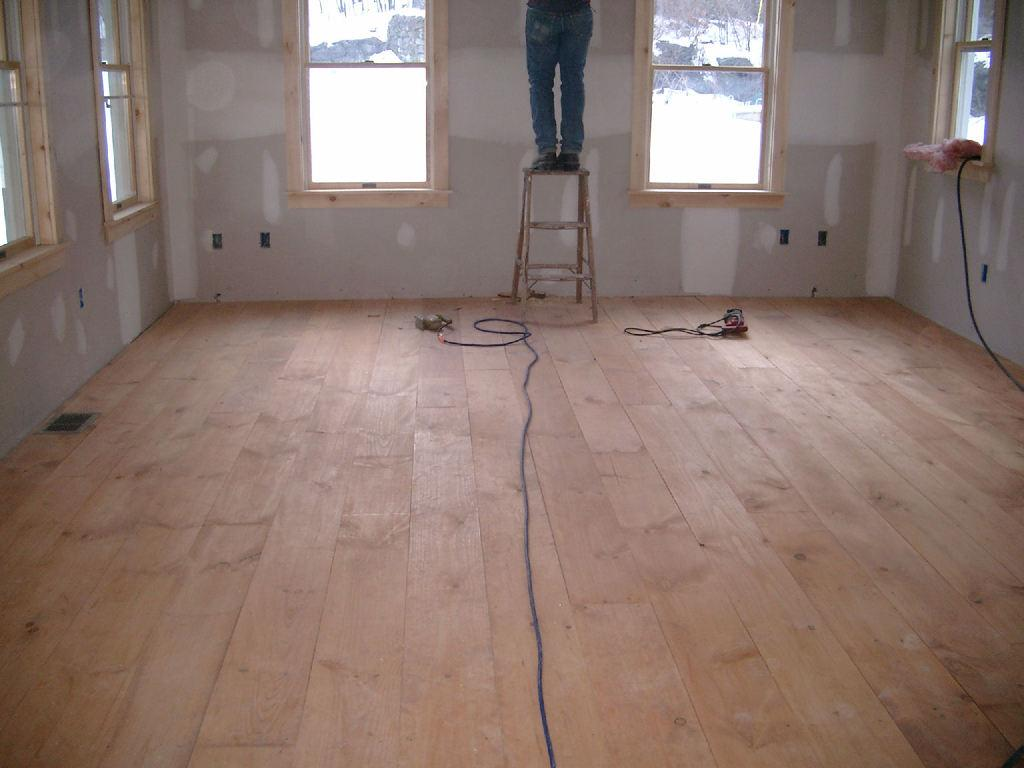What is the person sitting on in the image? The person is sitting on a stool in the image. What can be seen on the floor in the image? There are wires on the floor in the image. What is visible through the windows in the image? The presence of windows suggests that there is a view or outdoor scenery visible, but the specifics are not mentioned in the provided facts. What type of cloth is being used to whip the person in the image? There is no cloth or whipping action present in the image; it only shows a person sitting on a stool with wires on the floor and windows visible. 